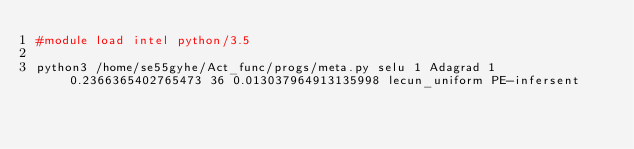<code> <loc_0><loc_0><loc_500><loc_500><_Bash_>#module load intel python/3.5

python3 /home/se55gyhe/Act_func/progs/meta.py selu 1 Adagrad 1 0.2366365402765473 36 0.013037964913135998 lecun_uniform PE-infersent 

</code> 